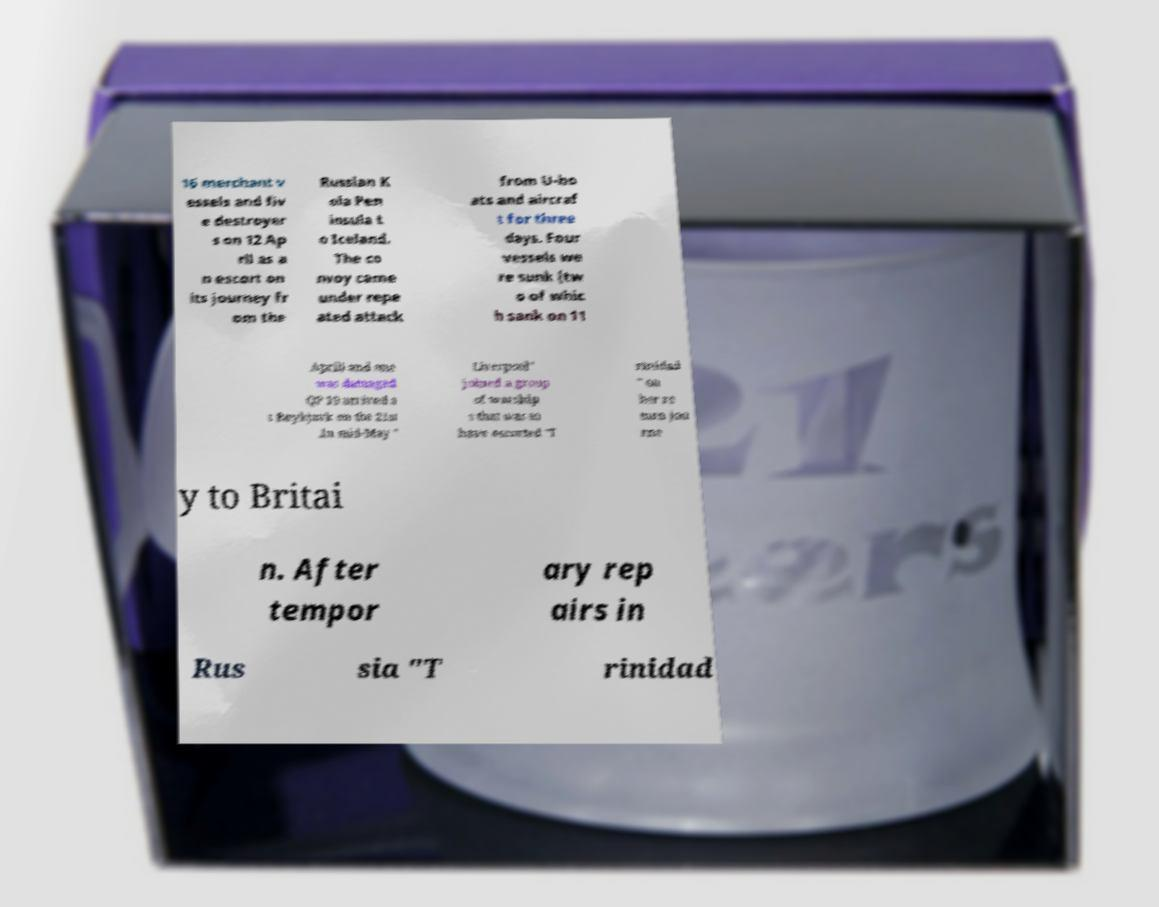Please identify and transcribe the text found in this image. 16 merchant v essels and fiv e destroyer s on 12 Ap ril as a n escort on its journey fr om the Russian K ola Pen insula t o Iceland. The co nvoy came under repe ated attack from U-bo ats and aircraf t for three days. Four vessels we re sunk (tw o of whic h sank on 11 April) and one was damaged QP 10 arrived a t Reykjavk on the 21st .In mid-May " Liverpool" joined a group of warship s that was to have escorted "T rinidad " on her re turn jou rne y to Britai n. After tempor ary rep airs in Rus sia "T rinidad 